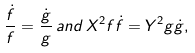Convert formula to latex. <formula><loc_0><loc_0><loc_500><loc_500>\frac { \dot { f } } { f } = \frac { \dot { g } } { g } \, { a n d } \, X ^ { 2 } f \dot { f } = Y ^ { 2 } g \dot { g } ,</formula> 